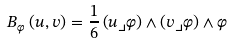Convert formula to latex. <formula><loc_0><loc_0><loc_500><loc_500>B _ { \varphi } \left ( u , v \right ) = \frac { 1 } { 6 } \left ( u \lrcorner \varphi \right ) \wedge \left ( v \lrcorner \varphi \right ) \wedge \varphi</formula> 